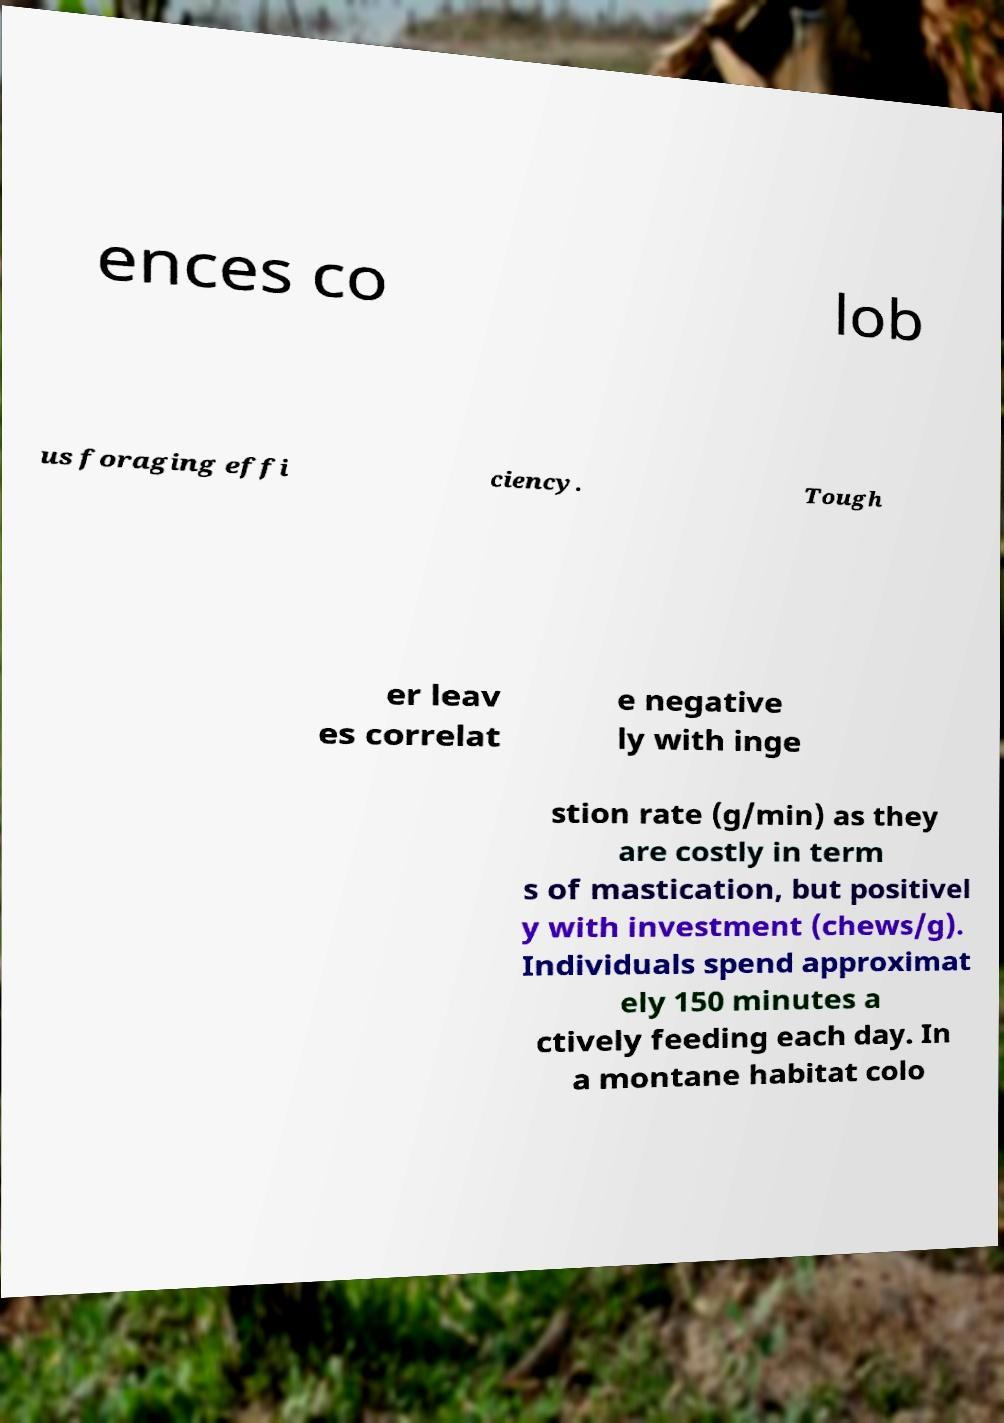There's text embedded in this image that I need extracted. Can you transcribe it verbatim? ences co lob us foraging effi ciency. Tough er leav es correlat e negative ly with inge stion rate (g/min) as they are costly in term s of mastication, but positivel y with investment (chews/g). Individuals spend approximat ely 150 minutes a ctively feeding each day. In a montane habitat colo 